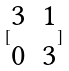Convert formula to latex. <formula><loc_0><loc_0><loc_500><loc_500>[ \begin{matrix} 3 & 1 \\ 0 & 3 \end{matrix} ]</formula> 